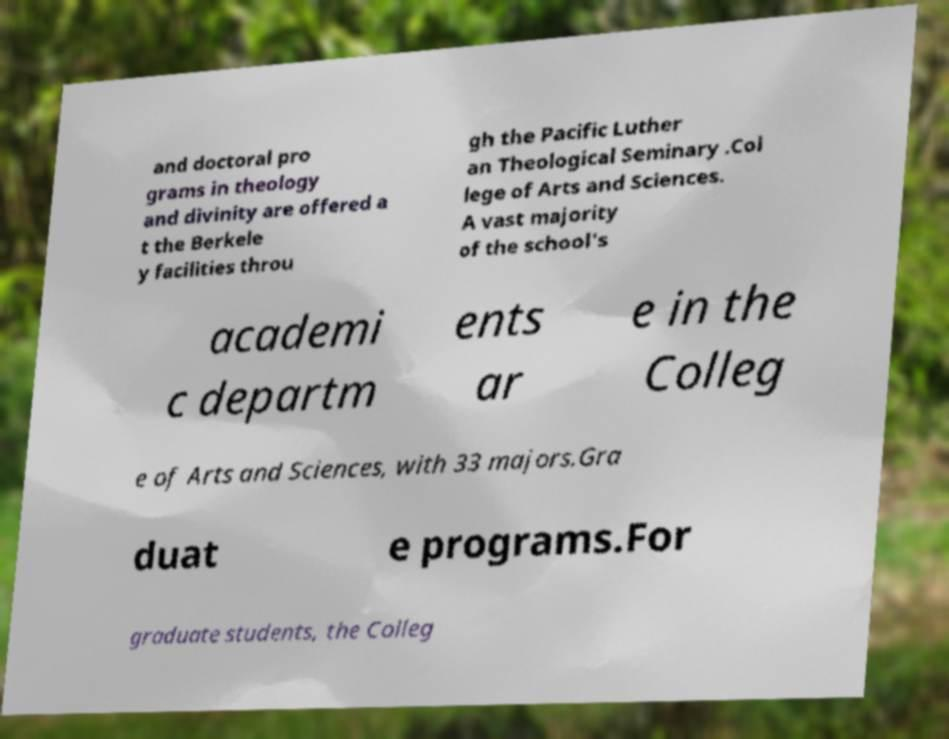Could you assist in decoding the text presented in this image and type it out clearly? and doctoral pro grams in theology and divinity are offered a t the Berkele y facilities throu gh the Pacific Luther an Theological Seminary .Col lege of Arts and Sciences. A vast majority of the school's academi c departm ents ar e in the Colleg e of Arts and Sciences, with 33 majors.Gra duat e programs.For graduate students, the Colleg 